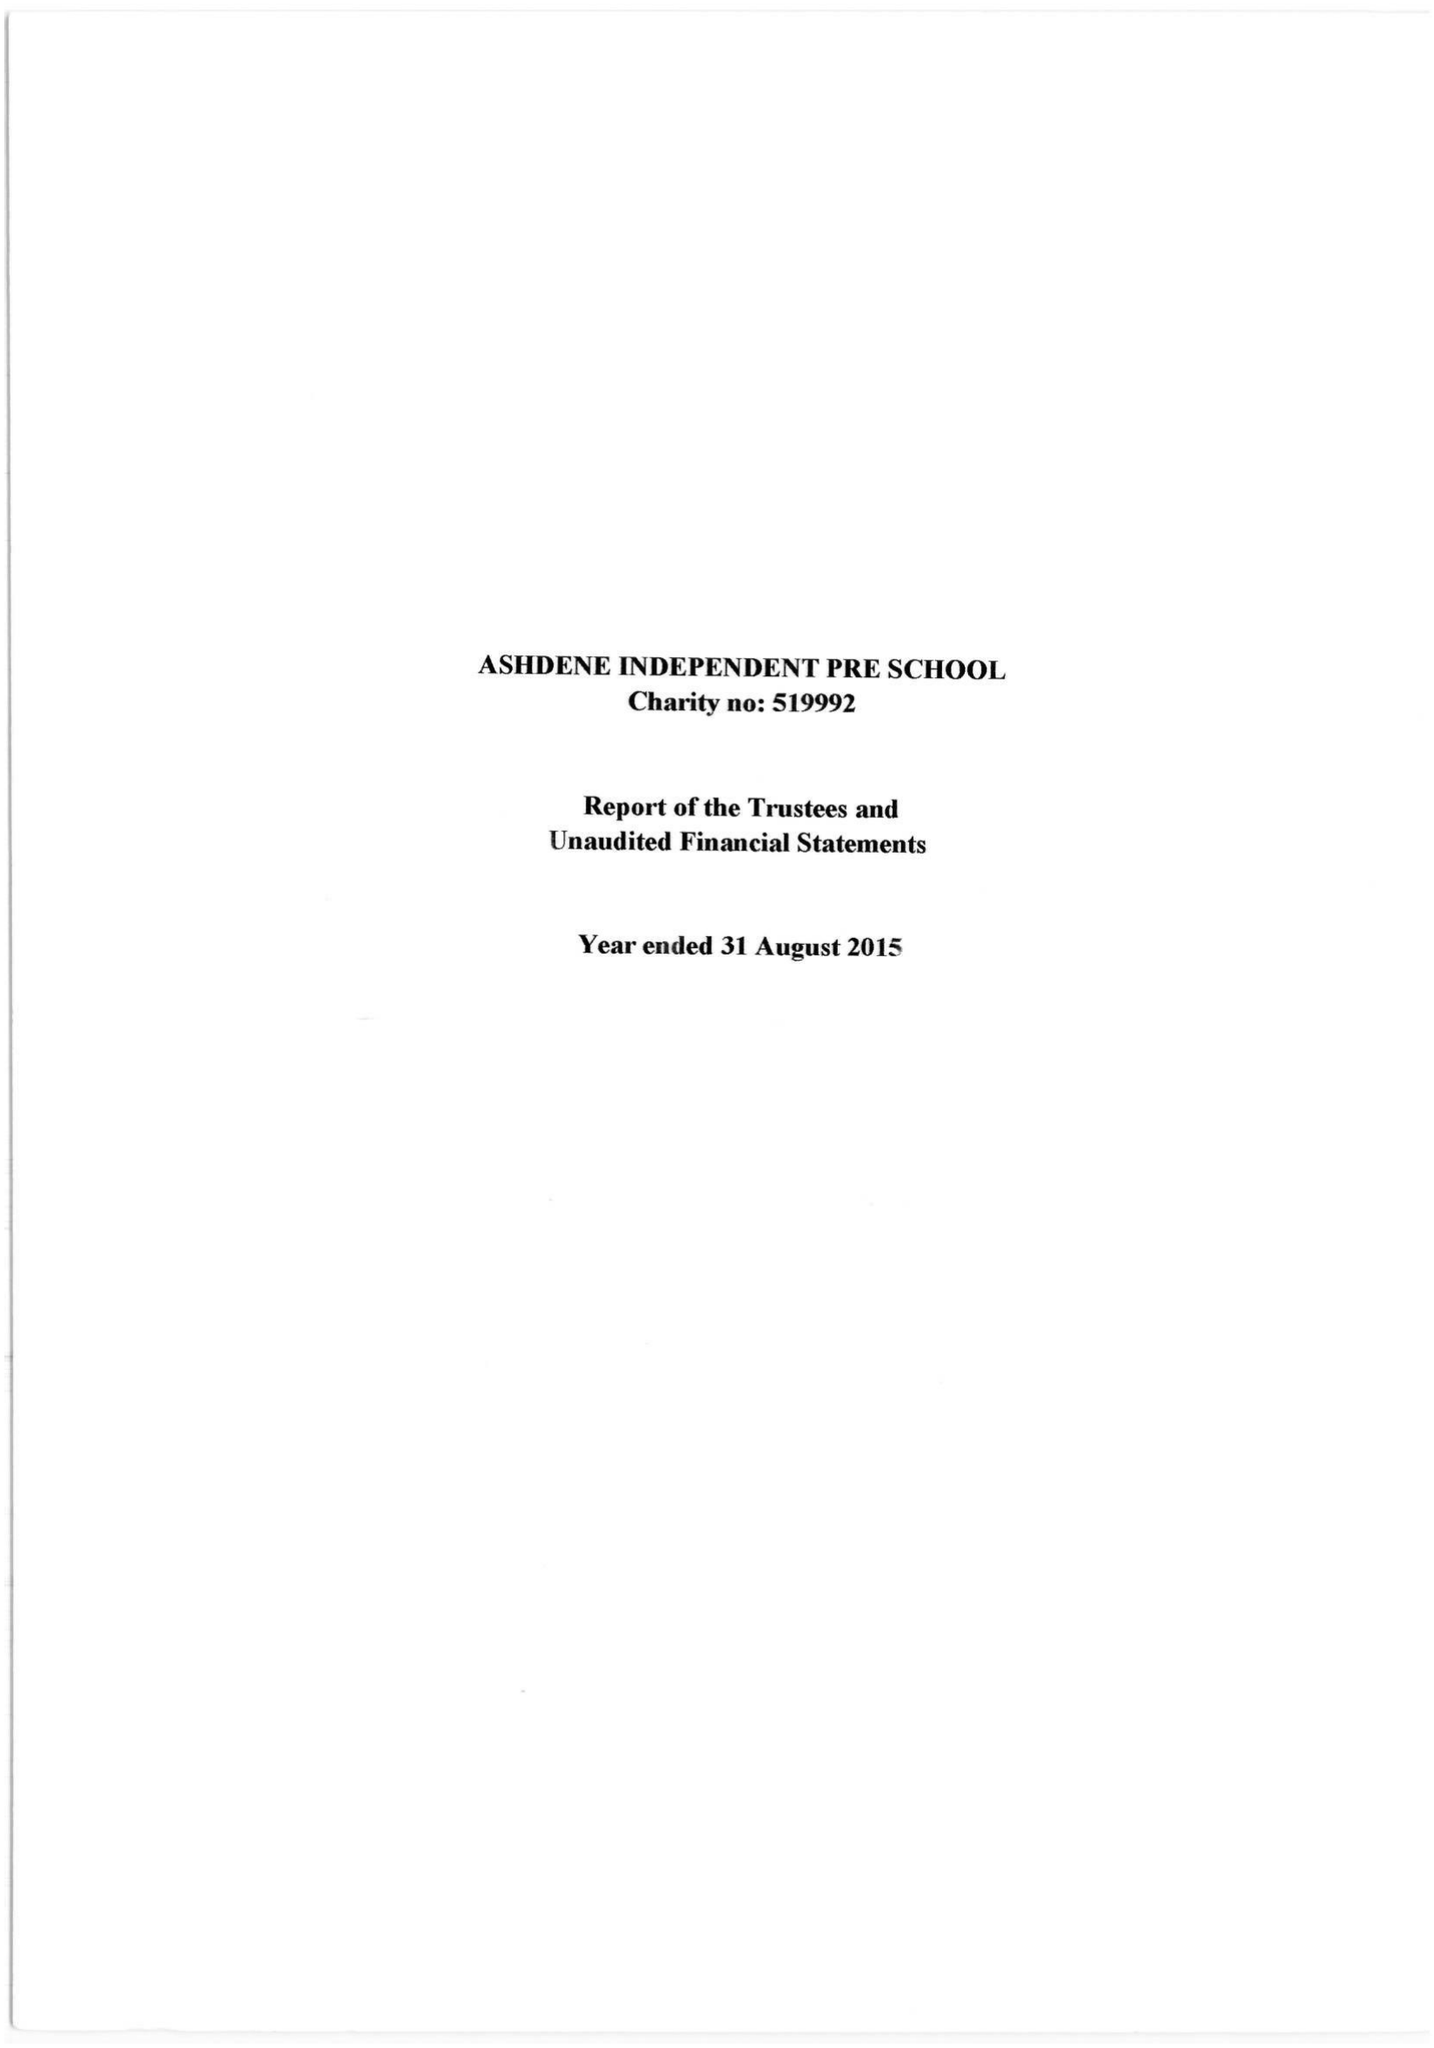What is the value for the charity_name?
Answer the question using a single word or phrase. Ashdene Independent Pre-School 